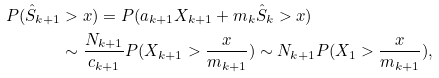<formula> <loc_0><loc_0><loc_500><loc_500>P ( \hat { S } _ { k + 1 } & > x ) = P ( a _ { k + 1 } X _ { k + 1 } + m _ { k } \hat { S } _ { k } > x ) \\ & \sim \frac { N _ { k + 1 } } { c _ { k + 1 } } P ( X _ { k + 1 } > \frac { x } { m _ { k + 1 } } ) \sim N _ { k + 1 } P ( X _ { 1 } > \frac { x } { m _ { k + 1 } } ) ,</formula> 